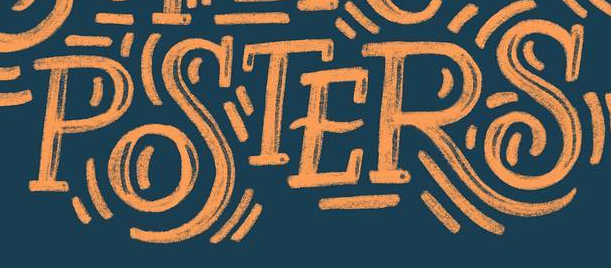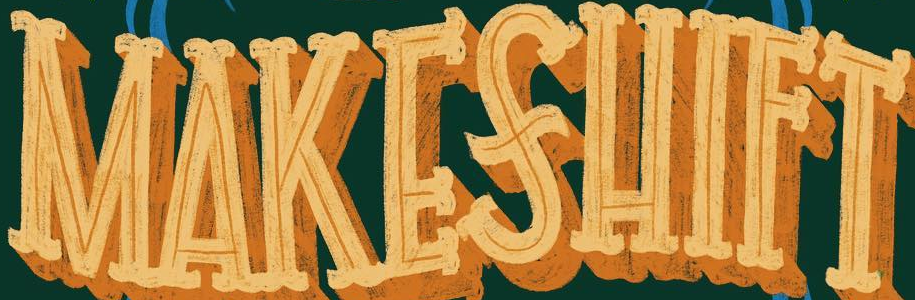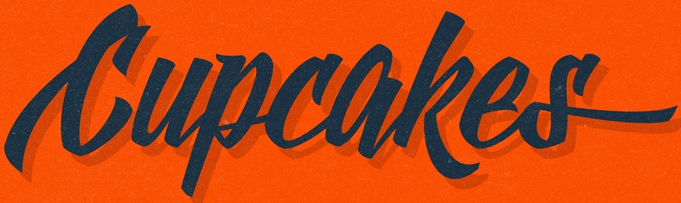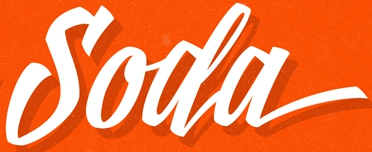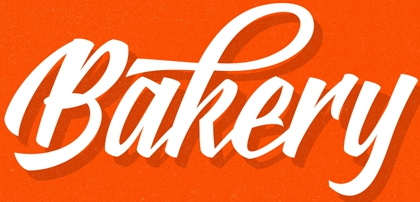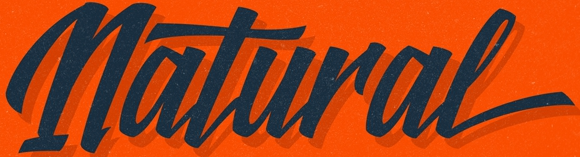Read the text from these images in sequence, separated by a semicolon. POSTERS; MAKESHIFT; Cupcakes; Soda; Bakery; Natural 